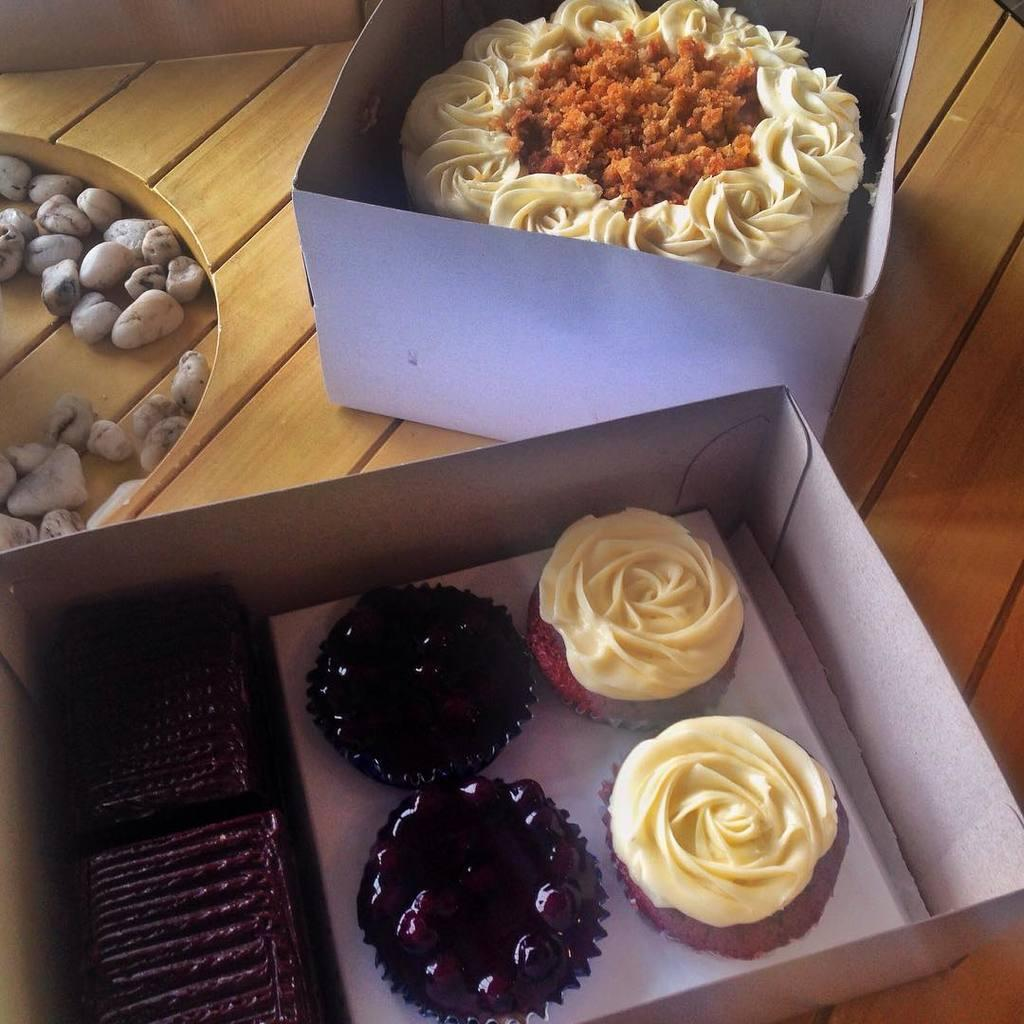What is the main object at the center of the image? There is a table at the center of the image. What is placed on the table? There is a box with cake on the table, and another box with a food item. Can you describe the contents of the boxes on the table? One box contains cake, and the other box contains a different food item. How many bridges can be seen crossing the river in the image? There is no river or bridge present in the image; it features a table with boxes containing cake and another food item. What type of force is being applied to the scissors in the image? There are no scissors present in the image. 